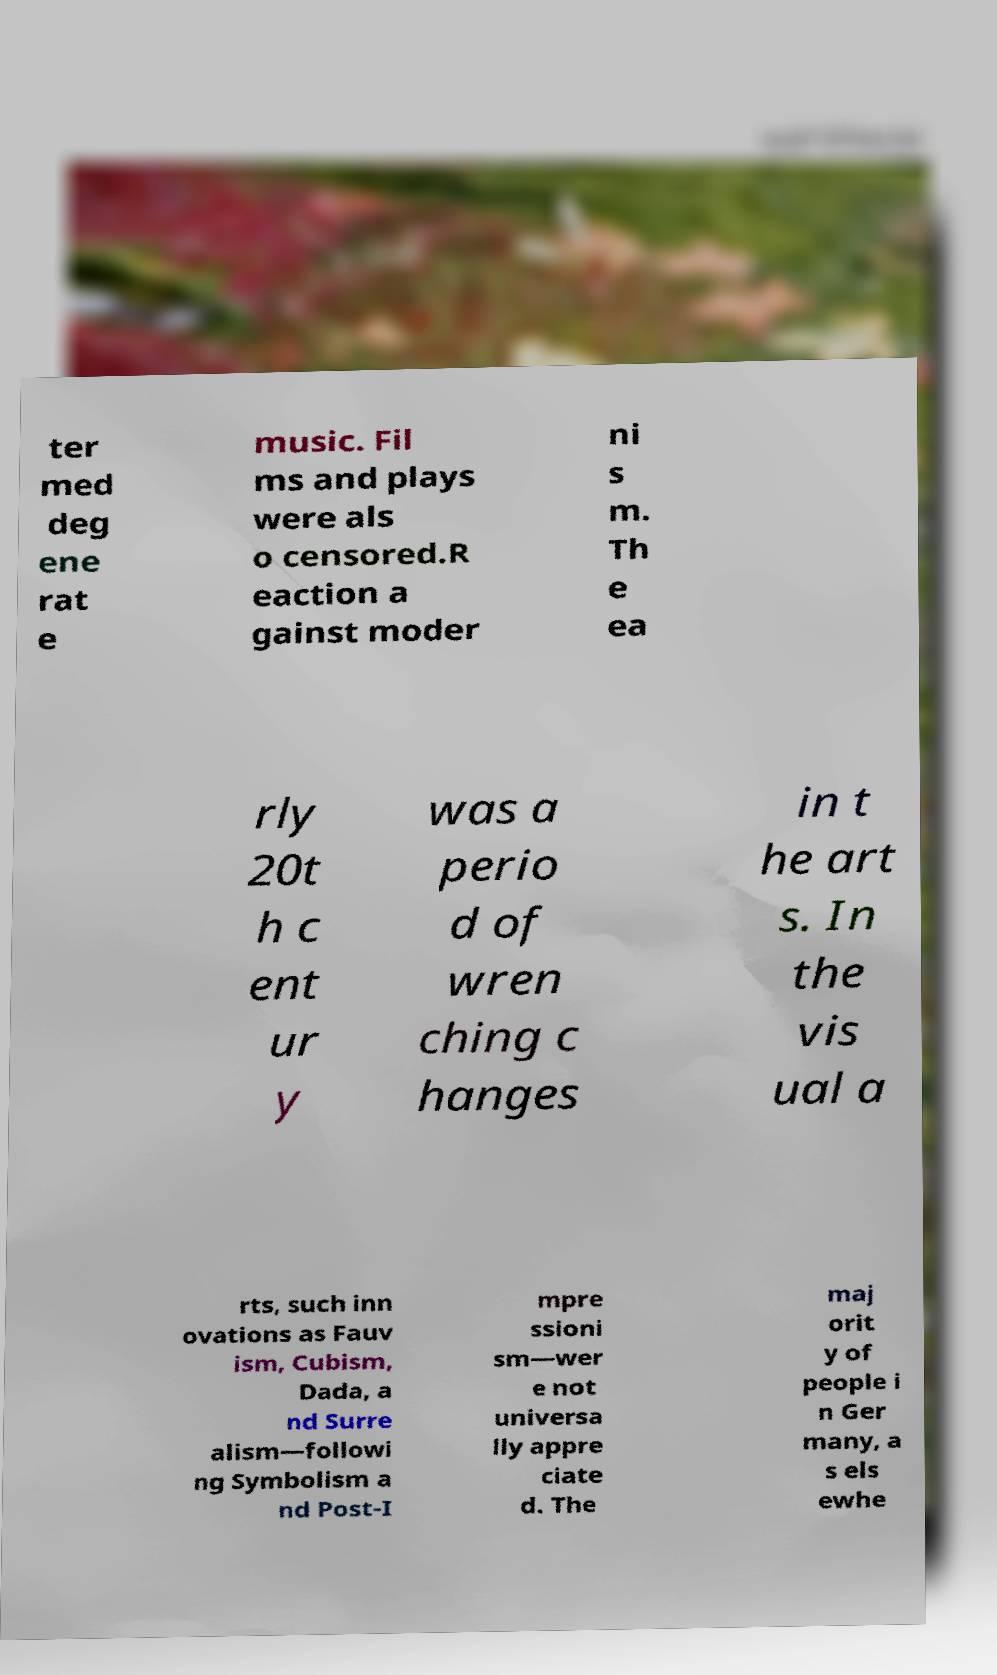I need the written content from this picture converted into text. Can you do that? ter med deg ene rat e music. Fil ms and plays were als o censored.R eaction a gainst moder ni s m. Th e ea rly 20t h c ent ur y was a perio d of wren ching c hanges in t he art s. In the vis ual a rts, such inn ovations as Fauv ism, Cubism, Dada, a nd Surre alism—followi ng Symbolism a nd Post-I mpre ssioni sm—wer e not universa lly appre ciate d. The maj orit y of people i n Ger many, a s els ewhe 